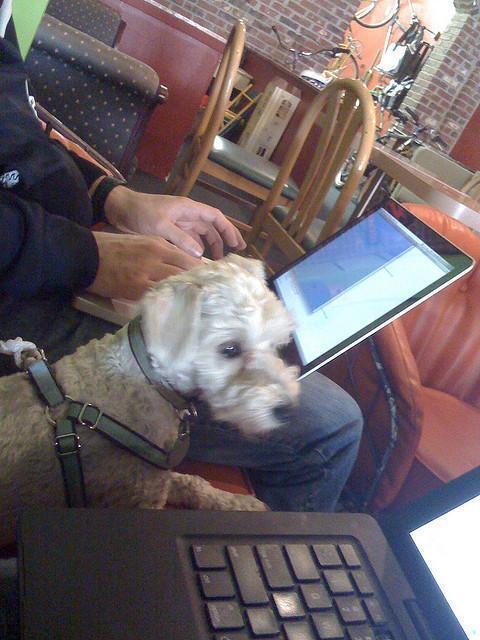How many laptops are in the photo?
Give a very brief answer. 2. How many chairs are visible?
Give a very brief answer. 3. How many couches are there?
Give a very brief answer. 2. How many bicycles can be seen?
Give a very brief answer. 2. 